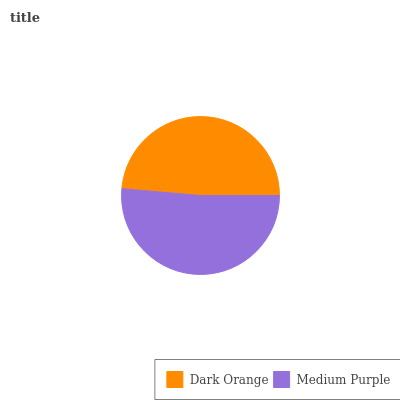Is Dark Orange the minimum?
Answer yes or no. Yes. Is Medium Purple the maximum?
Answer yes or no. Yes. Is Medium Purple the minimum?
Answer yes or no. No. Is Medium Purple greater than Dark Orange?
Answer yes or no. Yes. Is Dark Orange less than Medium Purple?
Answer yes or no. Yes. Is Dark Orange greater than Medium Purple?
Answer yes or no. No. Is Medium Purple less than Dark Orange?
Answer yes or no. No. Is Medium Purple the high median?
Answer yes or no. Yes. Is Dark Orange the low median?
Answer yes or no. Yes. Is Dark Orange the high median?
Answer yes or no. No. Is Medium Purple the low median?
Answer yes or no. No. 